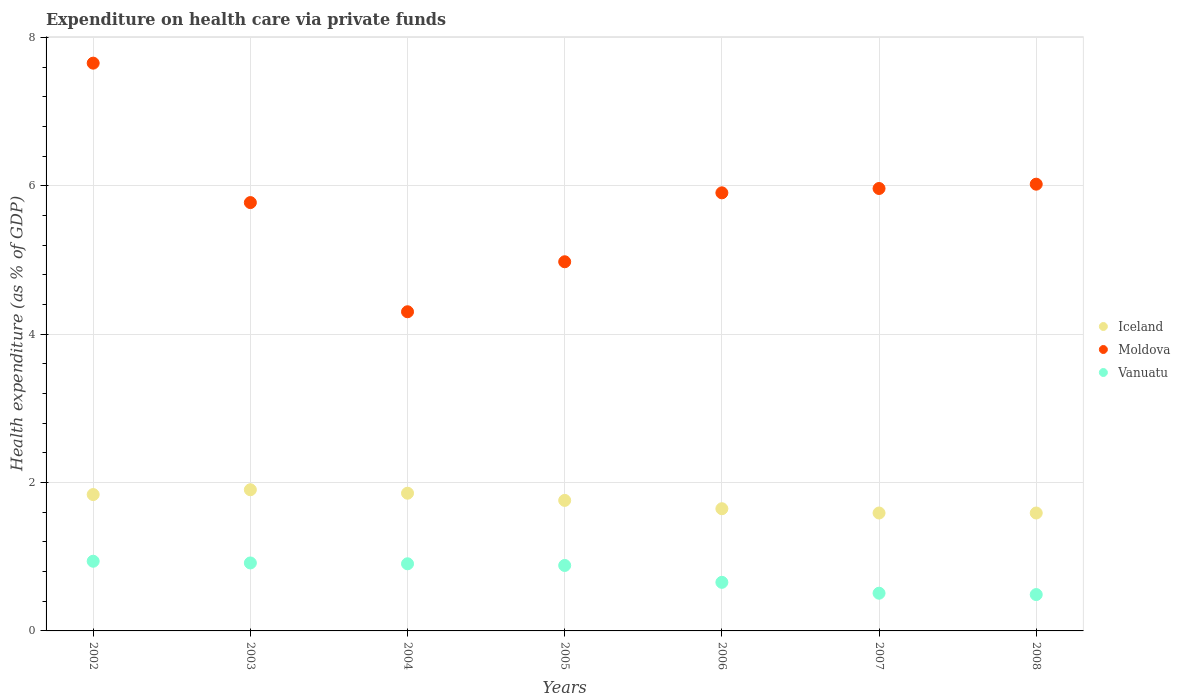How many different coloured dotlines are there?
Your answer should be compact. 3. Is the number of dotlines equal to the number of legend labels?
Give a very brief answer. Yes. What is the expenditure made on health care in Vanuatu in 2006?
Your answer should be very brief. 0.66. Across all years, what is the maximum expenditure made on health care in Vanuatu?
Keep it short and to the point. 0.94. Across all years, what is the minimum expenditure made on health care in Vanuatu?
Your answer should be very brief. 0.49. In which year was the expenditure made on health care in Vanuatu maximum?
Keep it short and to the point. 2002. What is the total expenditure made on health care in Iceland in the graph?
Ensure brevity in your answer.  12.19. What is the difference between the expenditure made on health care in Vanuatu in 2003 and that in 2007?
Make the answer very short. 0.41. What is the difference between the expenditure made on health care in Iceland in 2006 and the expenditure made on health care in Vanuatu in 2003?
Provide a succinct answer. 0.73. What is the average expenditure made on health care in Vanuatu per year?
Offer a terse response. 0.76. In the year 2007, what is the difference between the expenditure made on health care in Vanuatu and expenditure made on health care in Iceland?
Provide a succinct answer. -1.08. What is the ratio of the expenditure made on health care in Iceland in 2002 to that in 2005?
Keep it short and to the point. 1.04. Is the expenditure made on health care in Vanuatu in 2002 less than that in 2007?
Your response must be concise. No. What is the difference between the highest and the second highest expenditure made on health care in Iceland?
Provide a short and direct response. 0.05. What is the difference between the highest and the lowest expenditure made on health care in Vanuatu?
Provide a short and direct response. 0.45. In how many years, is the expenditure made on health care in Moldova greater than the average expenditure made on health care in Moldova taken over all years?
Make the answer very short. 4. Is the sum of the expenditure made on health care in Moldova in 2003 and 2007 greater than the maximum expenditure made on health care in Vanuatu across all years?
Give a very brief answer. Yes. Is it the case that in every year, the sum of the expenditure made on health care in Iceland and expenditure made on health care in Vanuatu  is greater than the expenditure made on health care in Moldova?
Your answer should be compact. No. Is the expenditure made on health care in Moldova strictly less than the expenditure made on health care in Iceland over the years?
Offer a terse response. No. Are the values on the major ticks of Y-axis written in scientific E-notation?
Offer a very short reply. No. What is the title of the graph?
Provide a short and direct response. Expenditure on health care via private funds. What is the label or title of the X-axis?
Give a very brief answer. Years. What is the label or title of the Y-axis?
Your answer should be compact. Health expenditure (as % of GDP). What is the Health expenditure (as % of GDP) of Iceland in 2002?
Offer a terse response. 1.84. What is the Health expenditure (as % of GDP) in Moldova in 2002?
Keep it short and to the point. 7.65. What is the Health expenditure (as % of GDP) of Vanuatu in 2002?
Offer a very short reply. 0.94. What is the Health expenditure (as % of GDP) in Iceland in 2003?
Your answer should be compact. 1.9. What is the Health expenditure (as % of GDP) in Moldova in 2003?
Your answer should be very brief. 5.78. What is the Health expenditure (as % of GDP) of Vanuatu in 2003?
Your answer should be compact. 0.92. What is the Health expenditure (as % of GDP) of Iceland in 2004?
Offer a terse response. 1.86. What is the Health expenditure (as % of GDP) in Moldova in 2004?
Give a very brief answer. 4.3. What is the Health expenditure (as % of GDP) of Vanuatu in 2004?
Your response must be concise. 0.91. What is the Health expenditure (as % of GDP) in Iceland in 2005?
Give a very brief answer. 1.76. What is the Health expenditure (as % of GDP) of Moldova in 2005?
Your answer should be very brief. 4.98. What is the Health expenditure (as % of GDP) of Vanuatu in 2005?
Provide a short and direct response. 0.88. What is the Health expenditure (as % of GDP) in Iceland in 2006?
Make the answer very short. 1.65. What is the Health expenditure (as % of GDP) of Moldova in 2006?
Ensure brevity in your answer.  5.91. What is the Health expenditure (as % of GDP) in Vanuatu in 2006?
Give a very brief answer. 0.66. What is the Health expenditure (as % of GDP) of Iceland in 2007?
Provide a succinct answer. 1.59. What is the Health expenditure (as % of GDP) in Moldova in 2007?
Offer a very short reply. 5.96. What is the Health expenditure (as % of GDP) in Vanuatu in 2007?
Provide a succinct answer. 0.51. What is the Health expenditure (as % of GDP) in Iceland in 2008?
Keep it short and to the point. 1.59. What is the Health expenditure (as % of GDP) of Moldova in 2008?
Your response must be concise. 6.02. What is the Health expenditure (as % of GDP) in Vanuatu in 2008?
Provide a succinct answer. 0.49. Across all years, what is the maximum Health expenditure (as % of GDP) of Iceland?
Make the answer very short. 1.9. Across all years, what is the maximum Health expenditure (as % of GDP) in Moldova?
Offer a very short reply. 7.65. Across all years, what is the maximum Health expenditure (as % of GDP) of Vanuatu?
Your response must be concise. 0.94. Across all years, what is the minimum Health expenditure (as % of GDP) of Iceland?
Provide a short and direct response. 1.59. Across all years, what is the minimum Health expenditure (as % of GDP) of Moldova?
Your answer should be very brief. 4.3. Across all years, what is the minimum Health expenditure (as % of GDP) of Vanuatu?
Your answer should be compact. 0.49. What is the total Health expenditure (as % of GDP) of Iceland in the graph?
Provide a short and direct response. 12.19. What is the total Health expenditure (as % of GDP) in Moldova in the graph?
Offer a very short reply. 40.6. What is the total Health expenditure (as % of GDP) in Vanuatu in the graph?
Your answer should be compact. 5.3. What is the difference between the Health expenditure (as % of GDP) of Iceland in 2002 and that in 2003?
Offer a very short reply. -0.06. What is the difference between the Health expenditure (as % of GDP) in Moldova in 2002 and that in 2003?
Make the answer very short. 1.88. What is the difference between the Health expenditure (as % of GDP) in Vanuatu in 2002 and that in 2003?
Offer a very short reply. 0.02. What is the difference between the Health expenditure (as % of GDP) of Iceland in 2002 and that in 2004?
Provide a short and direct response. -0.02. What is the difference between the Health expenditure (as % of GDP) of Moldova in 2002 and that in 2004?
Offer a very short reply. 3.35. What is the difference between the Health expenditure (as % of GDP) of Vanuatu in 2002 and that in 2004?
Provide a short and direct response. 0.03. What is the difference between the Health expenditure (as % of GDP) in Iceland in 2002 and that in 2005?
Give a very brief answer. 0.08. What is the difference between the Health expenditure (as % of GDP) of Moldova in 2002 and that in 2005?
Provide a succinct answer. 2.68. What is the difference between the Health expenditure (as % of GDP) of Vanuatu in 2002 and that in 2005?
Make the answer very short. 0.06. What is the difference between the Health expenditure (as % of GDP) of Iceland in 2002 and that in 2006?
Offer a terse response. 0.19. What is the difference between the Health expenditure (as % of GDP) of Moldova in 2002 and that in 2006?
Your response must be concise. 1.75. What is the difference between the Health expenditure (as % of GDP) in Vanuatu in 2002 and that in 2006?
Give a very brief answer. 0.28. What is the difference between the Health expenditure (as % of GDP) of Iceland in 2002 and that in 2007?
Provide a short and direct response. 0.25. What is the difference between the Health expenditure (as % of GDP) of Moldova in 2002 and that in 2007?
Make the answer very short. 1.69. What is the difference between the Health expenditure (as % of GDP) of Vanuatu in 2002 and that in 2007?
Provide a short and direct response. 0.43. What is the difference between the Health expenditure (as % of GDP) of Iceland in 2002 and that in 2008?
Ensure brevity in your answer.  0.25. What is the difference between the Health expenditure (as % of GDP) of Moldova in 2002 and that in 2008?
Provide a short and direct response. 1.63. What is the difference between the Health expenditure (as % of GDP) of Vanuatu in 2002 and that in 2008?
Provide a succinct answer. 0.45. What is the difference between the Health expenditure (as % of GDP) in Iceland in 2003 and that in 2004?
Ensure brevity in your answer.  0.05. What is the difference between the Health expenditure (as % of GDP) of Moldova in 2003 and that in 2004?
Offer a very short reply. 1.47. What is the difference between the Health expenditure (as % of GDP) in Vanuatu in 2003 and that in 2004?
Ensure brevity in your answer.  0.01. What is the difference between the Health expenditure (as % of GDP) of Iceland in 2003 and that in 2005?
Make the answer very short. 0.14. What is the difference between the Health expenditure (as % of GDP) in Moldova in 2003 and that in 2005?
Provide a short and direct response. 0.8. What is the difference between the Health expenditure (as % of GDP) of Vanuatu in 2003 and that in 2005?
Your response must be concise. 0.03. What is the difference between the Health expenditure (as % of GDP) of Iceland in 2003 and that in 2006?
Offer a very short reply. 0.26. What is the difference between the Health expenditure (as % of GDP) in Moldova in 2003 and that in 2006?
Your answer should be very brief. -0.13. What is the difference between the Health expenditure (as % of GDP) in Vanuatu in 2003 and that in 2006?
Keep it short and to the point. 0.26. What is the difference between the Health expenditure (as % of GDP) of Iceland in 2003 and that in 2007?
Offer a very short reply. 0.31. What is the difference between the Health expenditure (as % of GDP) in Moldova in 2003 and that in 2007?
Provide a succinct answer. -0.19. What is the difference between the Health expenditure (as % of GDP) in Vanuatu in 2003 and that in 2007?
Offer a terse response. 0.41. What is the difference between the Health expenditure (as % of GDP) in Iceland in 2003 and that in 2008?
Offer a very short reply. 0.31. What is the difference between the Health expenditure (as % of GDP) of Moldova in 2003 and that in 2008?
Give a very brief answer. -0.25. What is the difference between the Health expenditure (as % of GDP) of Vanuatu in 2003 and that in 2008?
Your answer should be compact. 0.43. What is the difference between the Health expenditure (as % of GDP) in Iceland in 2004 and that in 2005?
Provide a short and direct response. 0.1. What is the difference between the Health expenditure (as % of GDP) of Moldova in 2004 and that in 2005?
Offer a terse response. -0.67. What is the difference between the Health expenditure (as % of GDP) in Vanuatu in 2004 and that in 2005?
Make the answer very short. 0.02. What is the difference between the Health expenditure (as % of GDP) in Iceland in 2004 and that in 2006?
Keep it short and to the point. 0.21. What is the difference between the Health expenditure (as % of GDP) in Moldova in 2004 and that in 2006?
Your answer should be very brief. -1.6. What is the difference between the Health expenditure (as % of GDP) in Vanuatu in 2004 and that in 2006?
Offer a terse response. 0.25. What is the difference between the Health expenditure (as % of GDP) of Iceland in 2004 and that in 2007?
Provide a short and direct response. 0.27. What is the difference between the Health expenditure (as % of GDP) of Moldova in 2004 and that in 2007?
Provide a succinct answer. -1.66. What is the difference between the Health expenditure (as % of GDP) of Vanuatu in 2004 and that in 2007?
Provide a short and direct response. 0.4. What is the difference between the Health expenditure (as % of GDP) in Iceland in 2004 and that in 2008?
Your response must be concise. 0.27. What is the difference between the Health expenditure (as % of GDP) of Moldova in 2004 and that in 2008?
Offer a very short reply. -1.72. What is the difference between the Health expenditure (as % of GDP) of Vanuatu in 2004 and that in 2008?
Your answer should be compact. 0.41. What is the difference between the Health expenditure (as % of GDP) of Iceland in 2005 and that in 2006?
Provide a succinct answer. 0.11. What is the difference between the Health expenditure (as % of GDP) of Moldova in 2005 and that in 2006?
Give a very brief answer. -0.93. What is the difference between the Health expenditure (as % of GDP) in Vanuatu in 2005 and that in 2006?
Provide a short and direct response. 0.23. What is the difference between the Health expenditure (as % of GDP) in Iceland in 2005 and that in 2007?
Your response must be concise. 0.17. What is the difference between the Health expenditure (as % of GDP) of Moldova in 2005 and that in 2007?
Ensure brevity in your answer.  -0.99. What is the difference between the Health expenditure (as % of GDP) in Vanuatu in 2005 and that in 2007?
Offer a very short reply. 0.37. What is the difference between the Health expenditure (as % of GDP) in Iceland in 2005 and that in 2008?
Your answer should be compact. 0.17. What is the difference between the Health expenditure (as % of GDP) of Moldova in 2005 and that in 2008?
Make the answer very short. -1.05. What is the difference between the Health expenditure (as % of GDP) of Vanuatu in 2005 and that in 2008?
Keep it short and to the point. 0.39. What is the difference between the Health expenditure (as % of GDP) of Iceland in 2006 and that in 2007?
Your answer should be very brief. 0.06. What is the difference between the Health expenditure (as % of GDP) in Moldova in 2006 and that in 2007?
Make the answer very short. -0.06. What is the difference between the Health expenditure (as % of GDP) in Vanuatu in 2006 and that in 2007?
Your response must be concise. 0.15. What is the difference between the Health expenditure (as % of GDP) of Iceland in 2006 and that in 2008?
Make the answer very short. 0.06. What is the difference between the Health expenditure (as % of GDP) of Moldova in 2006 and that in 2008?
Your answer should be very brief. -0.12. What is the difference between the Health expenditure (as % of GDP) of Vanuatu in 2006 and that in 2008?
Make the answer very short. 0.16. What is the difference between the Health expenditure (as % of GDP) in Iceland in 2007 and that in 2008?
Your answer should be compact. 0. What is the difference between the Health expenditure (as % of GDP) in Moldova in 2007 and that in 2008?
Give a very brief answer. -0.06. What is the difference between the Health expenditure (as % of GDP) in Vanuatu in 2007 and that in 2008?
Offer a terse response. 0.02. What is the difference between the Health expenditure (as % of GDP) in Iceland in 2002 and the Health expenditure (as % of GDP) in Moldova in 2003?
Offer a terse response. -3.94. What is the difference between the Health expenditure (as % of GDP) of Iceland in 2002 and the Health expenditure (as % of GDP) of Vanuatu in 2003?
Ensure brevity in your answer.  0.92. What is the difference between the Health expenditure (as % of GDP) in Moldova in 2002 and the Health expenditure (as % of GDP) in Vanuatu in 2003?
Offer a terse response. 6.74. What is the difference between the Health expenditure (as % of GDP) of Iceland in 2002 and the Health expenditure (as % of GDP) of Moldova in 2004?
Provide a short and direct response. -2.46. What is the difference between the Health expenditure (as % of GDP) in Iceland in 2002 and the Health expenditure (as % of GDP) in Vanuatu in 2004?
Your answer should be very brief. 0.93. What is the difference between the Health expenditure (as % of GDP) in Moldova in 2002 and the Health expenditure (as % of GDP) in Vanuatu in 2004?
Offer a very short reply. 6.75. What is the difference between the Health expenditure (as % of GDP) of Iceland in 2002 and the Health expenditure (as % of GDP) of Moldova in 2005?
Provide a short and direct response. -3.14. What is the difference between the Health expenditure (as % of GDP) in Iceland in 2002 and the Health expenditure (as % of GDP) in Vanuatu in 2005?
Offer a terse response. 0.96. What is the difference between the Health expenditure (as % of GDP) in Moldova in 2002 and the Health expenditure (as % of GDP) in Vanuatu in 2005?
Offer a terse response. 6.77. What is the difference between the Health expenditure (as % of GDP) of Iceland in 2002 and the Health expenditure (as % of GDP) of Moldova in 2006?
Keep it short and to the point. -4.07. What is the difference between the Health expenditure (as % of GDP) in Iceland in 2002 and the Health expenditure (as % of GDP) in Vanuatu in 2006?
Your answer should be compact. 1.18. What is the difference between the Health expenditure (as % of GDP) in Iceland in 2002 and the Health expenditure (as % of GDP) in Moldova in 2007?
Keep it short and to the point. -4.13. What is the difference between the Health expenditure (as % of GDP) in Iceland in 2002 and the Health expenditure (as % of GDP) in Vanuatu in 2007?
Give a very brief answer. 1.33. What is the difference between the Health expenditure (as % of GDP) in Moldova in 2002 and the Health expenditure (as % of GDP) in Vanuatu in 2007?
Provide a succinct answer. 7.15. What is the difference between the Health expenditure (as % of GDP) in Iceland in 2002 and the Health expenditure (as % of GDP) in Moldova in 2008?
Keep it short and to the point. -4.18. What is the difference between the Health expenditure (as % of GDP) in Iceland in 2002 and the Health expenditure (as % of GDP) in Vanuatu in 2008?
Provide a succinct answer. 1.35. What is the difference between the Health expenditure (as % of GDP) of Moldova in 2002 and the Health expenditure (as % of GDP) of Vanuatu in 2008?
Keep it short and to the point. 7.16. What is the difference between the Health expenditure (as % of GDP) in Iceland in 2003 and the Health expenditure (as % of GDP) in Moldova in 2004?
Make the answer very short. -2.4. What is the difference between the Health expenditure (as % of GDP) of Moldova in 2003 and the Health expenditure (as % of GDP) of Vanuatu in 2004?
Your response must be concise. 4.87. What is the difference between the Health expenditure (as % of GDP) of Iceland in 2003 and the Health expenditure (as % of GDP) of Moldova in 2005?
Provide a succinct answer. -3.07. What is the difference between the Health expenditure (as % of GDP) in Iceland in 2003 and the Health expenditure (as % of GDP) in Vanuatu in 2005?
Offer a terse response. 1.02. What is the difference between the Health expenditure (as % of GDP) of Moldova in 2003 and the Health expenditure (as % of GDP) of Vanuatu in 2005?
Ensure brevity in your answer.  4.89. What is the difference between the Health expenditure (as % of GDP) in Iceland in 2003 and the Health expenditure (as % of GDP) in Moldova in 2006?
Your response must be concise. -4. What is the difference between the Health expenditure (as % of GDP) in Iceland in 2003 and the Health expenditure (as % of GDP) in Vanuatu in 2006?
Your response must be concise. 1.25. What is the difference between the Health expenditure (as % of GDP) of Moldova in 2003 and the Health expenditure (as % of GDP) of Vanuatu in 2006?
Provide a succinct answer. 5.12. What is the difference between the Health expenditure (as % of GDP) in Iceland in 2003 and the Health expenditure (as % of GDP) in Moldova in 2007?
Your answer should be very brief. -4.06. What is the difference between the Health expenditure (as % of GDP) in Iceland in 2003 and the Health expenditure (as % of GDP) in Vanuatu in 2007?
Offer a very short reply. 1.4. What is the difference between the Health expenditure (as % of GDP) in Moldova in 2003 and the Health expenditure (as % of GDP) in Vanuatu in 2007?
Your answer should be compact. 5.27. What is the difference between the Health expenditure (as % of GDP) of Iceland in 2003 and the Health expenditure (as % of GDP) of Moldova in 2008?
Keep it short and to the point. -4.12. What is the difference between the Health expenditure (as % of GDP) of Iceland in 2003 and the Health expenditure (as % of GDP) of Vanuatu in 2008?
Offer a terse response. 1.41. What is the difference between the Health expenditure (as % of GDP) of Moldova in 2003 and the Health expenditure (as % of GDP) of Vanuatu in 2008?
Offer a very short reply. 5.28. What is the difference between the Health expenditure (as % of GDP) of Iceland in 2004 and the Health expenditure (as % of GDP) of Moldova in 2005?
Provide a short and direct response. -3.12. What is the difference between the Health expenditure (as % of GDP) in Iceland in 2004 and the Health expenditure (as % of GDP) in Vanuatu in 2005?
Keep it short and to the point. 0.97. What is the difference between the Health expenditure (as % of GDP) of Moldova in 2004 and the Health expenditure (as % of GDP) of Vanuatu in 2005?
Provide a succinct answer. 3.42. What is the difference between the Health expenditure (as % of GDP) of Iceland in 2004 and the Health expenditure (as % of GDP) of Moldova in 2006?
Your answer should be very brief. -4.05. What is the difference between the Health expenditure (as % of GDP) of Iceland in 2004 and the Health expenditure (as % of GDP) of Vanuatu in 2006?
Keep it short and to the point. 1.2. What is the difference between the Health expenditure (as % of GDP) in Moldova in 2004 and the Health expenditure (as % of GDP) in Vanuatu in 2006?
Ensure brevity in your answer.  3.65. What is the difference between the Health expenditure (as % of GDP) of Iceland in 2004 and the Health expenditure (as % of GDP) of Moldova in 2007?
Offer a very short reply. -4.11. What is the difference between the Health expenditure (as % of GDP) in Iceland in 2004 and the Health expenditure (as % of GDP) in Vanuatu in 2007?
Ensure brevity in your answer.  1.35. What is the difference between the Health expenditure (as % of GDP) of Moldova in 2004 and the Health expenditure (as % of GDP) of Vanuatu in 2007?
Keep it short and to the point. 3.79. What is the difference between the Health expenditure (as % of GDP) of Iceland in 2004 and the Health expenditure (as % of GDP) of Moldova in 2008?
Make the answer very short. -4.17. What is the difference between the Health expenditure (as % of GDP) of Iceland in 2004 and the Health expenditure (as % of GDP) of Vanuatu in 2008?
Provide a short and direct response. 1.37. What is the difference between the Health expenditure (as % of GDP) of Moldova in 2004 and the Health expenditure (as % of GDP) of Vanuatu in 2008?
Provide a succinct answer. 3.81. What is the difference between the Health expenditure (as % of GDP) in Iceland in 2005 and the Health expenditure (as % of GDP) in Moldova in 2006?
Provide a short and direct response. -4.15. What is the difference between the Health expenditure (as % of GDP) of Iceland in 2005 and the Health expenditure (as % of GDP) of Vanuatu in 2006?
Offer a terse response. 1.1. What is the difference between the Health expenditure (as % of GDP) in Moldova in 2005 and the Health expenditure (as % of GDP) in Vanuatu in 2006?
Offer a very short reply. 4.32. What is the difference between the Health expenditure (as % of GDP) of Iceland in 2005 and the Health expenditure (as % of GDP) of Moldova in 2007?
Your response must be concise. -4.21. What is the difference between the Health expenditure (as % of GDP) in Iceland in 2005 and the Health expenditure (as % of GDP) in Vanuatu in 2007?
Keep it short and to the point. 1.25. What is the difference between the Health expenditure (as % of GDP) in Moldova in 2005 and the Health expenditure (as % of GDP) in Vanuatu in 2007?
Provide a succinct answer. 4.47. What is the difference between the Health expenditure (as % of GDP) of Iceland in 2005 and the Health expenditure (as % of GDP) of Moldova in 2008?
Make the answer very short. -4.26. What is the difference between the Health expenditure (as % of GDP) in Iceland in 2005 and the Health expenditure (as % of GDP) in Vanuatu in 2008?
Your answer should be very brief. 1.27. What is the difference between the Health expenditure (as % of GDP) in Moldova in 2005 and the Health expenditure (as % of GDP) in Vanuatu in 2008?
Offer a terse response. 4.49. What is the difference between the Health expenditure (as % of GDP) in Iceland in 2006 and the Health expenditure (as % of GDP) in Moldova in 2007?
Your answer should be very brief. -4.32. What is the difference between the Health expenditure (as % of GDP) of Iceland in 2006 and the Health expenditure (as % of GDP) of Vanuatu in 2007?
Your answer should be very brief. 1.14. What is the difference between the Health expenditure (as % of GDP) of Moldova in 2006 and the Health expenditure (as % of GDP) of Vanuatu in 2007?
Keep it short and to the point. 5.4. What is the difference between the Health expenditure (as % of GDP) of Iceland in 2006 and the Health expenditure (as % of GDP) of Moldova in 2008?
Offer a very short reply. -4.38. What is the difference between the Health expenditure (as % of GDP) in Iceland in 2006 and the Health expenditure (as % of GDP) in Vanuatu in 2008?
Keep it short and to the point. 1.16. What is the difference between the Health expenditure (as % of GDP) of Moldova in 2006 and the Health expenditure (as % of GDP) of Vanuatu in 2008?
Your response must be concise. 5.42. What is the difference between the Health expenditure (as % of GDP) in Iceland in 2007 and the Health expenditure (as % of GDP) in Moldova in 2008?
Your response must be concise. -4.43. What is the difference between the Health expenditure (as % of GDP) in Iceland in 2007 and the Health expenditure (as % of GDP) in Vanuatu in 2008?
Ensure brevity in your answer.  1.1. What is the difference between the Health expenditure (as % of GDP) in Moldova in 2007 and the Health expenditure (as % of GDP) in Vanuatu in 2008?
Provide a short and direct response. 5.47. What is the average Health expenditure (as % of GDP) in Iceland per year?
Offer a very short reply. 1.74. What is the average Health expenditure (as % of GDP) in Moldova per year?
Your answer should be very brief. 5.8. What is the average Health expenditure (as % of GDP) in Vanuatu per year?
Your answer should be compact. 0.76. In the year 2002, what is the difference between the Health expenditure (as % of GDP) of Iceland and Health expenditure (as % of GDP) of Moldova?
Your response must be concise. -5.82. In the year 2002, what is the difference between the Health expenditure (as % of GDP) of Iceland and Health expenditure (as % of GDP) of Vanuatu?
Your response must be concise. 0.9. In the year 2002, what is the difference between the Health expenditure (as % of GDP) of Moldova and Health expenditure (as % of GDP) of Vanuatu?
Give a very brief answer. 6.72. In the year 2003, what is the difference between the Health expenditure (as % of GDP) of Iceland and Health expenditure (as % of GDP) of Moldova?
Your answer should be compact. -3.87. In the year 2003, what is the difference between the Health expenditure (as % of GDP) of Moldova and Health expenditure (as % of GDP) of Vanuatu?
Make the answer very short. 4.86. In the year 2004, what is the difference between the Health expenditure (as % of GDP) in Iceland and Health expenditure (as % of GDP) in Moldova?
Your answer should be very brief. -2.45. In the year 2004, what is the difference between the Health expenditure (as % of GDP) of Iceland and Health expenditure (as % of GDP) of Vanuatu?
Ensure brevity in your answer.  0.95. In the year 2004, what is the difference between the Health expenditure (as % of GDP) of Moldova and Health expenditure (as % of GDP) of Vanuatu?
Provide a succinct answer. 3.4. In the year 2005, what is the difference between the Health expenditure (as % of GDP) in Iceland and Health expenditure (as % of GDP) in Moldova?
Keep it short and to the point. -3.22. In the year 2005, what is the difference between the Health expenditure (as % of GDP) in Iceland and Health expenditure (as % of GDP) in Vanuatu?
Provide a succinct answer. 0.88. In the year 2005, what is the difference between the Health expenditure (as % of GDP) in Moldova and Health expenditure (as % of GDP) in Vanuatu?
Keep it short and to the point. 4.09. In the year 2006, what is the difference between the Health expenditure (as % of GDP) in Iceland and Health expenditure (as % of GDP) in Moldova?
Offer a very short reply. -4.26. In the year 2006, what is the difference between the Health expenditure (as % of GDP) in Iceland and Health expenditure (as % of GDP) in Vanuatu?
Provide a succinct answer. 0.99. In the year 2006, what is the difference between the Health expenditure (as % of GDP) in Moldova and Health expenditure (as % of GDP) in Vanuatu?
Your response must be concise. 5.25. In the year 2007, what is the difference between the Health expenditure (as % of GDP) in Iceland and Health expenditure (as % of GDP) in Moldova?
Provide a short and direct response. -4.38. In the year 2007, what is the difference between the Health expenditure (as % of GDP) in Iceland and Health expenditure (as % of GDP) in Vanuatu?
Offer a very short reply. 1.08. In the year 2007, what is the difference between the Health expenditure (as % of GDP) in Moldova and Health expenditure (as % of GDP) in Vanuatu?
Ensure brevity in your answer.  5.46. In the year 2008, what is the difference between the Health expenditure (as % of GDP) of Iceland and Health expenditure (as % of GDP) of Moldova?
Offer a very short reply. -4.43. In the year 2008, what is the difference between the Health expenditure (as % of GDP) in Iceland and Health expenditure (as % of GDP) in Vanuatu?
Ensure brevity in your answer.  1.1. In the year 2008, what is the difference between the Health expenditure (as % of GDP) in Moldova and Health expenditure (as % of GDP) in Vanuatu?
Provide a short and direct response. 5.53. What is the ratio of the Health expenditure (as % of GDP) in Iceland in 2002 to that in 2003?
Your answer should be compact. 0.97. What is the ratio of the Health expenditure (as % of GDP) in Moldova in 2002 to that in 2003?
Ensure brevity in your answer.  1.33. What is the ratio of the Health expenditure (as % of GDP) in Vanuatu in 2002 to that in 2003?
Keep it short and to the point. 1.03. What is the ratio of the Health expenditure (as % of GDP) in Iceland in 2002 to that in 2004?
Provide a short and direct response. 0.99. What is the ratio of the Health expenditure (as % of GDP) of Moldova in 2002 to that in 2004?
Give a very brief answer. 1.78. What is the ratio of the Health expenditure (as % of GDP) of Vanuatu in 2002 to that in 2004?
Your response must be concise. 1.04. What is the ratio of the Health expenditure (as % of GDP) in Iceland in 2002 to that in 2005?
Give a very brief answer. 1.04. What is the ratio of the Health expenditure (as % of GDP) in Moldova in 2002 to that in 2005?
Keep it short and to the point. 1.54. What is the ratio of the Health expenditure (as % of GDP) of Vanuatu in 2002 to that in 2005?
Provide a succinct answer. 1.06. What is the ratio of the Health expenditure (as % of GDP) of Iceland in 2002 to that in 2006?
Offer a terse response. 1.12. What is the ratio of the Health expenditure (as % of GDP) of Moldova in 2002 to that in 2006?
Offer a very short reply. 1.3. What is the ratio of the Health expenditure (as % of GDP) in Vanuatu in 2002 to that in 2006?
Give a very brief answer. 1.43. What is the ratio of the Health expenditure (as % of GDP) in Iceland in 2002 to that in 2007?
Make the answer very short. 1.16. What is the ratio of the Health expenditure (as % of GDP) of Moldova in 2002 to that in 2007?
Give a very brief answer. 1.28. What is the ratio of the Health expenditure (as % of GDP) of Vanuatu in 2002 to that in 2007?
Give a very brief answer. 1.85. What is the ratio of the Health expenditure (as % of GDP) of Iceland in 2002 to that in 2008?
Keep it short and to the point. 1.16. What is the ratio of the Health expenditure (as % of GDP) in Moldova in 2002 to that in 2008?
Offer a terse response. 1.27. What is the ratio of the Health expenditure (as % of GDP) of Vanuatu in 2002 to that in 2008?
Provide a short and direct response. 1.92. What is the ratio of the Health expenditure (as % of GDP) in Iceland in 2003 to that in 2004?
Your answer should be compact. 1.03. What is the ratio of the Health expenditure (as % of GDP) of Moldova in 2003 to that in 2004?
Your answer should be compact. 1.34. What is the ratio of the Health expenditure (as % of GDP) of Vanuatu in 2003 to that in 2004?
Offer a terse response. 1.01. What is the ratio of the Health expenditure (as % of GDP) of Iceland in 2003 to that in 2005?
Provide a succinct answer. 1.08. What is the ratio of the Health expenditure (as % of GDP) of Moldova in 2003 to that in 2005?
Your answer should be very brief. 1.16. What is the ratio of the Health expenditure (as % of GDP) in Vanuatu in 2003 to that in 2005?
Offer a terse response. 1.04. What is the ratio of the Health expenditure (as % of GDP) of Iceland in 2003 to that in 2006?
Your answer should be very brief. 1.16. What is the ratio of the Health expenditure (as % of GDP) in Moldova in 2003 to that in 2006?
Your response must be concise. 0.98. What is the ratio of the Health expenditure (as % of GDP) of Vanuatu in 2003 to that in 2006?
Provide a short and direct response. 1.4. What is the ratio of the Health expenditure (as % of GDP) in Iceland in 2003 to that in 2007?
Your response must be concise. 1.2. What is the ratio of the Health expenditure (as % of GDP) of Moldova in 2003 to that in 2007?
Keep it short and to the point. 0.97. What is the ratio of the Health expenditure (as % of GDP) of Vanuatu in 2003 to that in 2007?
Give a very brief answer. 1.8. What is the ratio of the Health expenditure (as % of GDP) of Iceland in 2003 to that in 2008?
Make the answer very short. 1.2. What is the ratio of the Health expenditure (as % of GDP) in Moldova in 2003 to that in 2008?
Your answer should be compact. 0.96. What is the ratio of the Health expenditure (as % of GDP) in Vanuatu in 2003 to that in 2008?
Offer a terse response. 1.87. What is the ratio of the Health expenditure (as % of GDP) of Iceland in 2004 to that in 2005?
Provide a short and direct response. 1.06. What is the ratio of the Health expenditure (as % of GDP) in Moldova in 2004 to that in 2005?
Your answer should be compact. 0.86. What is the ratio of the Health expenditure (as % of GDP) in Vanuatu in 2004 to that in 2005?
Offer a very short reply. 1.03. What is the ratio of the Health expenditure (as % of GDP) of Iceland in 2004 to that in 2006?
Keep it short and to the point. 1.13. What is the ratio of the Health expenditure (as % of GDP) of Moldova in 2004 to that in 2006?
Offer a terse response. 0.73. What is the ratio of the Health expenditure (as % of GDP) of Vanuatu in 2004 to that in 2006?
Your response must be concise. 1.38. What is the ratio of the Health expenditure (as % of GDP) of Iceland in 2004 to that in 2007?
Your answer should be compact. 1.17. What is the ratio of the Health expenditure (as % of GDP) of Moldova in 2004 to that in 2007?
Give a very brief answer. 0.72. What is the ratio of the Health expenditure (as % of GDP) in Vanuatu in 2004 to that in 2007?
Ensure brevity in your answer.  1.78. What is the ratio of the Health expenditure (as % of GDP) of Iceland in 2004 to that in 2008?
Your answer should be very brief. 1.17. What is the ratio of the Health expenditure (as % of GDP) in Moldova in 2004 to that in 2008?
Offer a very short reply. 0.71. What is the ratio of the Health expenditure (as % of GDP) of Vanuatu in 2004 to that in 2008?
Your response must be concise. 1.85. What is the ratio of the Health expenditure (as % of GDP) in Iceland in 2005 to that in 2006?
Offer a terse response. 1.07. What is the ratio of the Health expenditure (as % of GDP) of Moldova in 2005 to that in 2006?
Your answer should be compact. 0.84. What is the ratio of the Health expenditure (as % of GDP) in Vanuatu in 2005 to that in 2006?
Give a very brief answer. 1.35. What is the ratio of the Health expenditure (as % of GDP) in Iceland in 2005 to that in 2007?
Provide a short and direct response. 1.11. What is the ratio of the Health expenditure (as % of GDP) in Moldova in 2005 to that in 2007?
Provide a short and direct response. 0.83. What is the ratio of the Health expenditure (as % of GDP) in Vanuatu in 2005 to that in 2007?
Provide a short and direct response. 1.74. What is the ratio of the Health expenditure (as % of GDP) in Iceland in 2005 to that in 2008?
Your response must be concise. 1.11. What is the ratio of the Health expenditure (as % of GDP) in Moldova in 2005 to that in 2008?
Provide a succinct answer. 0.83. What is the ratio of the Health expenditure (as % of GDP) of Vanuatu in 2005 to that in 2008?
Offer a terse response. 1.8. What is the ratio of the Health expenditure (as % of GDP) in Iceland in 2006 to that in 2007?
Your answer should be compact. 1.04. What is the ratio of the Health expenditure (as % of GDP) of Moldova in 2006 to that in 2007?
Offer a terse response. 0.99. What is the ratio of the Health expenditure (as % of GDP) in Vanuatu in 2006 to that in 2007?
Ensure brevity in your answer.  1.29. What is the ratio of the Health expenditure (as % of GDP) of Iceland in 2006 to that in 2008?
Provide a succinct answer. 1.04. What is the ratio of the Health expenditure (as % of GDP) of Moldova in 2006 to that in 2008?
Make the answer very short. 0.98. What is the ratio of the Health expenditure (as % of GDP) of Vanuatu in 2006 to that in 2008?
Make the answer very short. 1.34. What is the ratio of the Health expenditure (as % of GDP) in Moldova in 2007 to that in 2008?
Ensure brevity in your answer.  0.99. What is the ratio of the Health expenditure (as % of GDP) in Vanuatu in 2007 to that in 2008?
Your answer should be compact. 1.04. What is the difference between the highest and the second highest Health expenditure (as % of GDP) in Iceland?
Provide a short and direct response. 0.05. What is the difference between the highest and the second highest Health expenditure (as % of GDP) of Moldova?
Your response must be concise. 1.63. What is the difference between the highest and the second highest Health expenditure (as % of GDP) of Vanuatu?
Offer a terse response. 0.02. What is the difference between the highest and the lowest Health expenditure (as % of GDP) of Iceland?
Provide a short and direct response. 0.31. What is the difference between the highest and the lowest Health expenditure (as % of GDP) of Moldova?
Provide a short and direct response. 3.35. What is the difference between the highest and the lowest Health expenditure (as % of GDP) in Vanuatu?
Your answer should be compact. 0.45. 